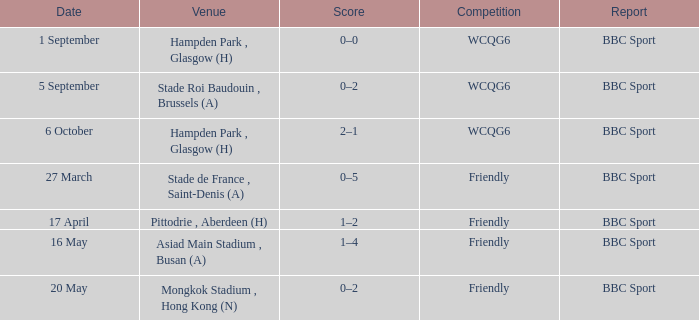Give me the full table as a dictionary. {'header': ['Date', 'Venue', 'Score', 'Competition', 'Report'], 'rows': [['1 September', 'Hampden Park , Glasgow (H)', '0–0', 'WCQG6', 'BBC Sport'], ['5 September', 'Stade Roi Baudouin , Brussels (A)', '0–2', 'WCQG6', 'BBC Sport'], ['6 October', 'Hampden Park , Glasgow (H)', '2–1', 'WCQG6', 'BBC Sport'], ['27 March', 'Stade de France , Saint-Denis (A)', '0–5', 'Friendly', 'BBC Sport'], ['17 April', 'Pittodrie , Aberdeen (H)', '1–2', 'Friendly', 'BBC Sport'], ['16 May', 'Asiad Main Stadium , Busan (A)', '1–4', 'Friendly', 'BBC Sport'], ['20 May', 'Mongkok Stadium , Hong Kong (N)', '0–2', 'Friendly', 'BBC Sport']]} Which individual gave an account of the game held on september 1st? BBC Sport. 